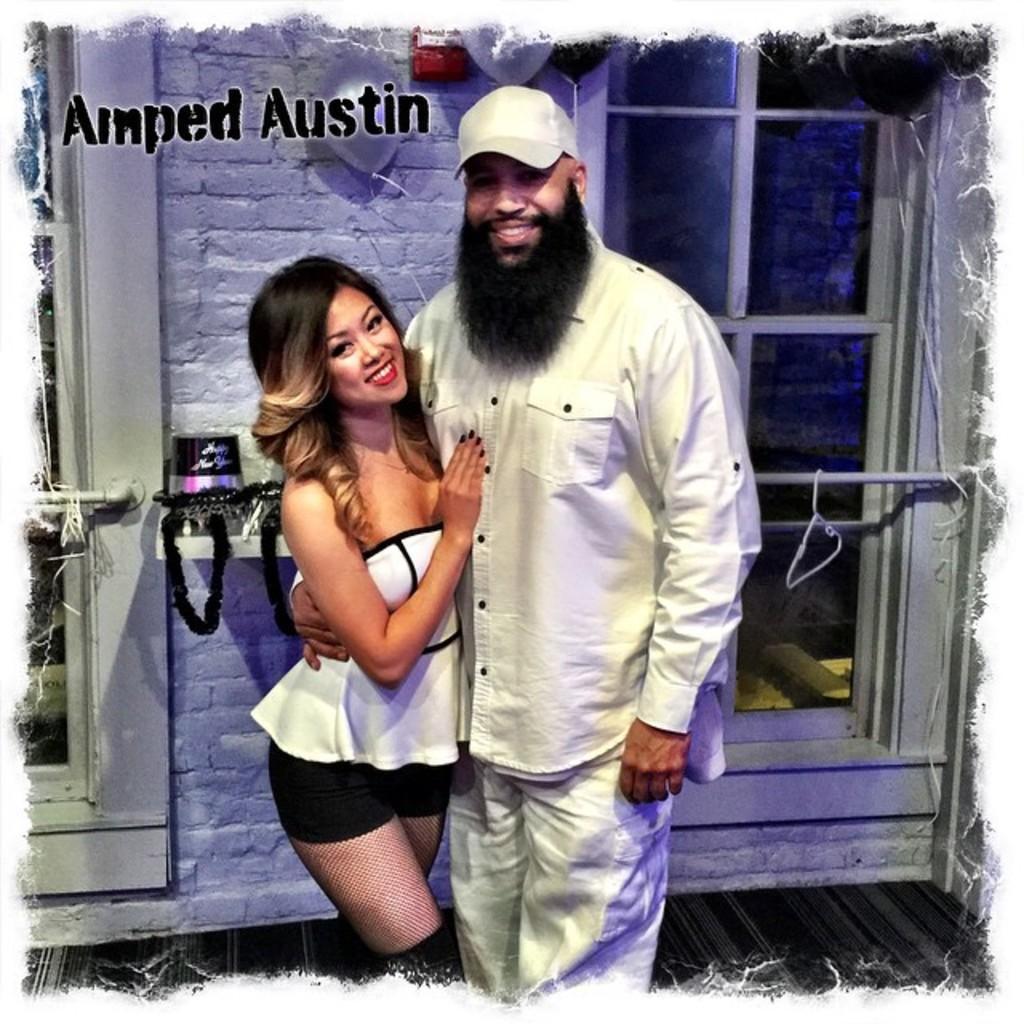Could you give a brief overview of what you see in this image? In this image there are two people standing with a smile on their face, behind them there is a wall with a few balloons and a few other objects placed on the rack and there are windows. 